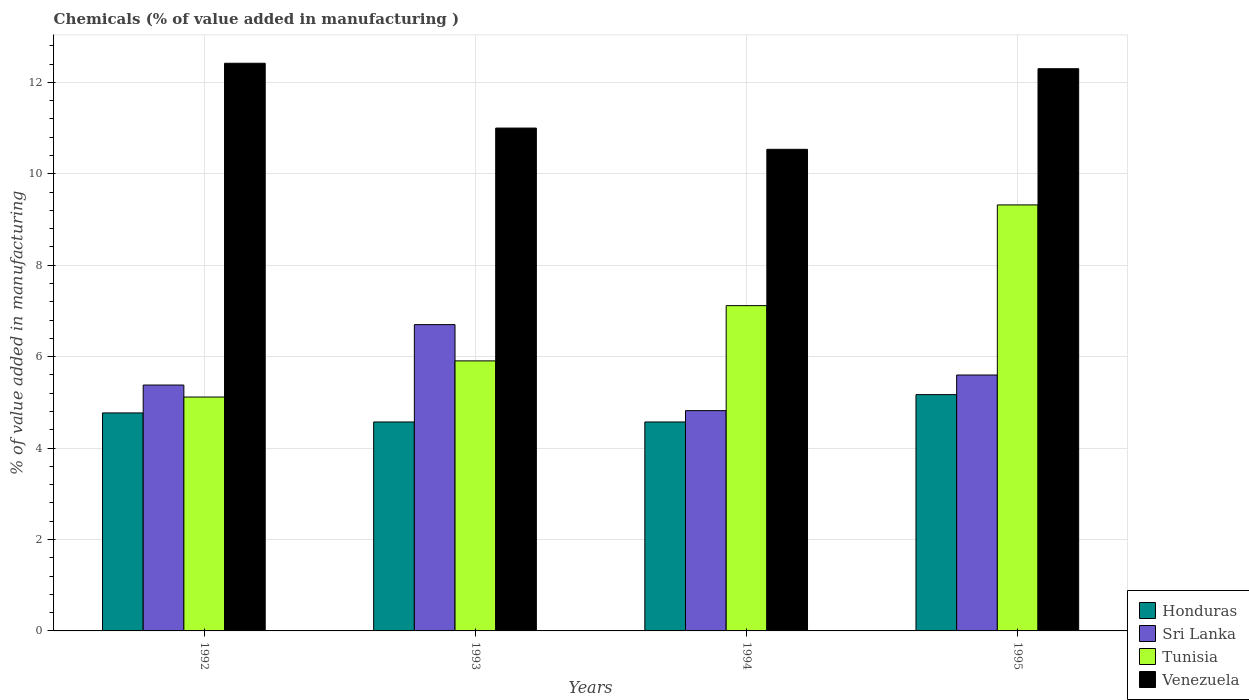What is the label of the 1st group of bars from the left?
Your answer should be compact. 1992. In how many cases, is the number of bars for a given year not equal to the number of legend labels?
Ensure brevity in your answer.  0. What is the value added in manufacturing chemicals in Sri Lanka in 1994?
Ensure brevity in your answer.  4.82. Across all years, what is the maximum value added in manufacturing chemicals in Honduras?
Provide a succinct answer. 5.17. Across all years, what is the minimum value added in manufacturing chemicals in Honduras?
Offer a very short reply. 4.57. What is the total value added in manufacturing chemicals in Sri Lanka in the graph?
Give a very brief answer. 22.5. What is the difference between the value added in manufacturing chemicals in Sri Lanka in 1992 and that in 1994?
Ensure brevity in your answer.  0.56. What is the difference between the value added in manufacturing chemicals in Sri Lanka in 1992 and the value added in manufacturing chemicals in Honduras in 1993?
Offer a terse response. 0.81. What is the average value added in manufacturing chemicals in Honduras per year?
Give a very brief answer. 4.77. In the year 1995, what is the difference between the value added in manufacturing chemicals in Sri Lanka and value added in manufacturing chemicals in Honduras?
Ensure brevity in your answer.  0.43. In how many years, is the value added in manufacturing chemicals in Sri Lanka greater than 3.2 %?
Keep it short and to the point. 4. What is the ratio of the value added in manufacturing chemicals in Venezuela in 1993 to that in 1994?
Your answer should be very brief. 1.04. Is the difference between the value added in manufacturing chemicals in Sri Lanka in 1992 and 1995 greater than the difference between the value added in manufacturing chemicals in Honduras in 1992 and 1995?
Ensure brevity in your answer.  Yes. What is the difference between the highest and the second highest value added in manufacturing chemicals in Tunisia?
Provide a succinct answer. 2.2. What is the difference between the highest and the lowest value added in manufacturing chemicals in Honduras?
Give a very brief answer. 0.6. Is it the case that in every year, the sum of the value added in manufacturing chemicals in Honduras and value added in manufacturing chemicals in Venezuela is greater than the sum of value added in manufacturing chemicals in Sri Lanka and value added in manufacturing chemicals in Tunisia?
Offer a terse response. Yes. What does the 4th bar from the left in 1995 represents?
Give a very brief answer. Venezuela. What does the 2nd bar from the right in 1992 represents?
Ensure brevity in your answer.  Tunisia. How many bars are there?
Your answer should be compact. 16. Are all the bars in the graph horizontal?
Provide a succinct answer. No. How many years are there in the graph?
Your answer should be very brief. 4. Are the values on the major ticks of Y-axis written in scientific E-notation?
Your answer should be compact. No. Does the graph contain any zero values?
Your response must be concise. No. How are the legend labels stacked?
Ensure brevity in your answer.  Vertical. What is the title of the graph?
Keep it short and to the point. Chemicals (% of value added in manufacturing ). What is the label or title of the Y-axis?
Your answer should be very brief. % of value added in manufacturing. What is the % of value added in manufacturing of Honduras in 1992?
Offer a very short reply. 4.77. What is the % of value added in manufacturing in Sri Lanka in 1992?
Make the answer very short. 5.38. What is the % of value added in manufacturing in Tunisia in 1992?
Offer a terse response. 5.12. What is the % of value added in manufacturing of Venezuela in 1992?
Your answer should be very brief. 12.42. What is the % of value added in manufacturing of Honduras in 1993?
Your answer should be very brief. 4.57. What is the % of value added in manufacturing of Sri Lanka in 1993?
Provide a succinct answer. 6.7. What is the % of value added in manufacturing of Tunisia in 1993?
Your answer should be compact. 5.91. What is the % of value added in manufacturing of Venezuela in 1993?
Provide a short and direct response. 11. What is the % of value added in manufacturing in Honduras in 1994?
Make the answer very short. 4.57. What is the % of value added in manufacturing of Sri Lanka in 1994?
Your answer should be compact. 4.82. What is the % of value added in manufacturing in Tunisia in 1994?
Provide a succinct answer. 7.12. What is the % of value added in manufacturing of Venezuela in 1994?
Offer a terse response. 10.54. What is the % of value added in manufacturing in Honduras in 1995?
Your response must be concise. 5.17. What is the % of value added in manufacturing in Sri Lanka in 1995?
Offer a very short reply. 5.6. What is the % of value added in manufacturing of Tunisia in 1995?
Your answer should be very brief. 9.32. What is the % of value added in manufacturing in Venezuela in 1995?
Your response must be concise. 12.3. Across all years, what is the maximum % of value added in manufacturing in Honduras?
Provide a short and direct response. 5.17. Across all years, what is the maximum % of value added in manufacturing in Sri Lanka?
Offer a terse response. 6.7. Across all years, what is the maximum % of value added in manufacturing of Tunisia?
Your answer should be very brief. 9.32. Across all years, what is the maximum % of value added in manufacturing of Venezuela?
Ensure brevity in your answer.  12.42. Across all years, what is the minimum % of value added in manufacturing of Honduras?
Give a very brief answer. 4.57. Across all years, what is the minimum % of value added in manufacturing of Sri Lanka?
Keep it short and to the point. 4.82. Across all years, what is the minimum % of value added in manufacturing of Tunisia?
Provide a succinct answer. 5.12. Across all years, what is the minimum % of value added in manufacturing in Venezuela?
Your answer should be very brief. 10.54. What is the total % of value added in manufacturing of Honduras in the graph?
Make the answer very short. 19.08. What is the total % of value added in manufacturing in Sri Lanka in the graph?
Make the answer very short. 22.5. What is the total % of value added in manufacturing of Tunisia in the graph?
Give a very brief answer. 27.46. What is the total % of value added in manufacturing of Venezuela in the graph?
Give a very brief answer. 46.25. What is the difference between the % of value added in manufacturing in Honduras in 1992 and that in 1993?
Make the answer very short. 0.2. What is the difference between the % of value added in manufacturing in Sri Lanka in 1992 and that in 1993?
Provide a short and direct response. -1.32. What is the difference between the % of value added in manufacturing of Tunisia in 1992 and that in 1993?
Ensure brevity in your answer.  -0.79. What is the difference between the % of value added in manufacturing of Venezuela in 1992 and that in 1993?
Offer a very short reply. 1.42. What is the difference between the % of value added in manufacturing of Honduras in 1992 and that in 1994?
Give a very brief answer. 0.2. What is the difference between the % of value added in manufacturing in Sri Lanka in 1992 and that in 1994?
Make the answer very short. 0.56. What is the difference between the % of value added in manufacturing of Tunisia in 1992 and that in 1994?
Keep it short and to the point. -2. What is the difference between the % of value added in manufacturing in Venezuela in 1992 and that in 1994?
Provide a short and direct response. 1.88. What is the difference between the % of value added in manufacturing of Honduras in 1992 and that in 1995?
Provide a short and direct response. -0.4. What is the difference between the % of value added in manufacturing in Sri Lanka in 1992 and that in 1995?
Ensure brevity in your answer.  -0.22. What is the difference between the % of value added in manufacturing of Tunisia in 1992 and that in 1995?
Give a very brief answer. -4.2. What is the difference between the % of value added in manufacturing in Venezuela in 1992 and that in 1995?
Make the answer very short. 0.12. What is the difference between the % of value added in manufacturing of Sri Lanka in 1993 and that in 1994?
Your answer should be very brief. 1.88. What is the difference between the % of value added in manufacturing of Tunisia in 1993 and that in 1994?
Provide a short and direct response. -1.21. What is the difference between the % of value added in manufacturing of Venezuela in 1993 and that in 1994?
Give a very brief answer. 0.47. What is the difference between the % of value added in manufacturing in Honduras in 1993 and that in 1995?
Provide a short and direct response. -0.6. What is the difference between the % of value added in manufacturing in Sri Lanka in 1993 and that in 1995?
Your response must be concise. 1.1. What is the difference between the % of value added in manufacturing in Tunisia in 1993 and that in 1995?
Your answer should be very brief. -3.41. What is the difference between the % of value added in manufacturing of Venezuela in 1993 and that in 1995?
Provide a short and direct response. -1.3. What is the difference between the % of value added in manufacturing in Honduras in 1994 and that in 1995?
Offer a terse response. -0.6. What is the difference between the % of value added in manufacturing of Sri Lanka in 1994 and that in 1995?
Offer a very short reply. -0.78. What is the difference between the % of value added in manufacturing of Tunisia in 1994 and that in 1995?
Give a very brief answer. -2.2. What is the difference between the % of value added in manufacturing of Venezuela in 1994 and that in 1995?
Provide a short and direct response. -1.76. What is the difference between the % of value added in manufacturing of Honduras in 1992 and the % of value added in manufacturing of Sri Lanka in 1993?
Give a very brief answer. -1.93. What is the difference between the % of value added in manufacturing of Honduras in 1992 and the % of value added in manufacturing of Tunisia in 1993?
Give a very brief answer. -1.14. What is the difference between the % of value added in manufacturing of Honduras in 1992 and the % of value added in manufacturing of Venezuela in 1993?
Your response must be concise. -6.23. What is the difference between the % of value added in manufacturing of Sri Lanka in 1992 and the % of value added in manufacturing of Tunisia in 1993?
Your answer should be compact. -0.53. What is the difference between the % of value added in manufacturing in Sri Lanka in 1992 and the % of value added in manufacturing in Venezuela in 1993?
Your answer should be compact. -5.62. What is the difference between the % of value added in manufacturing in Tunisia in 1992 and the % of value added in manufacturing in Venezuela in 1993?
Offer a terse response. -5.88. What is the difference between the % of value added in manufacturing in Honduras in 1992 and the % of value added in manufacturing in Sri Lanka in 1994?
Make the answer very short. -0.05. What is the difference between the % of value added in manufacturing of Honduras in 1992 and the % of value added in manufacturing of Tunisia in 1994?
Make the answer very short. -2.35. What is the difference between the % of value added in manufacturing in Honduras in 1992 and the % of value added in manufacturing in Venezuela in 1994?
Keep it short and to the point. -5.77. What is the difference between the % of value added in manufacturing of Sri Lanka in 1992 and the % of value added in manufacturing of Tunisia in 1994?
Give a very brief answer. -1.74. What is the difference between the % of value added in manufacturing of Sri Lanka in 1992 and the % of value added in manufacturing of Venezuela in 1994?
Give a very brief answer. -5.16. What is the difference between the % of value added in manufacturing of Tunisia in 1992 and the % of value added in manufacturing of Venezuela in 1994?
Give a very brief answer. -5.42. What is the difference between the % of value added in manufacturing of Honduras in 1992 and the % of value added in manufacturing of Sri Lanka in 1995?
Provide a succinct answer. -0.83. What is the difference between the % of value added in manufacturing of Honduras in 1992 and the % of value added in manufacturing of Tunisia in 1995?
Offer a very short reply. -4.55. What is the difference between the % of value added in manufacturing of Honduras in 1992 and the % of value added in manufacturing of Venezuela in 1995?
Your response must be concise. -7.53. What is the difference between the % of value added in manufacturing in Sri Lanka in 1992 and the % of value added in manufacturing in Tunisia in 1995?
Offer a very short reply. -3.94. What is the difference between the % of value added in manufacturing in Sri Lanka in 1992 and the % of value added in manufacturing in Venezuela in 1995?
Provide a succinct answer. -6.92. What is the difference between the % of value added in manufacturing of Tunisia in 1992 and the % of value added in manufacturing of Venezuela in 1995?
Offer a very short reply. -7.18. What is the difference between the % of value added in manufacturing of Honduras in 1993 and the % of value added in manufacturing of Sri Lanka in 1994?
Provide a succinct answer. -0.25. What is the difference between the % of value added in manufacturing in Honduras in 1993 and the % of value added in manufacturing in Tunisia in 1994?
Provide a succinct answer. -2.55. What is the difference between the % of value added in manufacturing of Honduras in 1993 and the % of value added in manufacturing of Venezuela in 1994?
Your answer should be compact. -5.96. What is the difference between the % of value added in manufacturing of Sri Lanka in 1993 and the % of value added in manufacturing of Tunisia in 1994?
Offer a very short reply. -0.42. What is the difference between the % of value added in manufacturing of Sri Lanka in 1993 and the % of value added in manufacturing of Venezuela in 1994?
Ensure brevity in your answer.  -3.83. What is the difference between the % of value added in manufacturing in Tunisia in 1993 and the % of value added in manufacturing in Venezuela in 1994?
Your response must be concise. -4.63. What is the difference between the % of value added in manufacturing in Honduras in 1993 and the % of value added in manufacturing in Sri Lanka in 1995?
Provide a succinct answer. -1.03. What is the difference between the % of value added in manufacturing in Honduras in 1993 and the % of value added in manufacturing in Tunisia in 1995?
Offer a terse response. -4.75. What is the difference between the % of value added in manufacturing in Honduras in 1993 and the % of value added in manufacturing in Venezuela in 1995?
Your response must be concise. -7.73. What is the difference between the % of value added in manufacturing of Sri Lanka in 1993 and the % of value added in manufacturing of Tunisia in 1995?
Keep it short and to the point. -2.62. What is the difference between the % of value added in manufacturing of Sri Lanka in 1993 and the % of value added in manufacturing of Venezuela in 1995?
Make the answer very short. -5.6. What is the difference between the % of value added in manufacturing in Tunisia in 1993 and the % of value added in manufacturing in Venezuela in 1995?
Your answer should be very brief. -6.39. What is the difference between the % of value added in manufacturing of Honduras in 1994 and the % of value added in manufacturing of Sri Lanka in 1995?
Ensure brevity in your answer.  -1.03. What is the difference between the % of value added in manufacturing in Honduras in 1994 and the % of value added in manufacturing in Tunisia in 1995?
Keep it short and to the point. -4.75. What is the difference between the % of value added in manufacturing in Honduras in 1994 and the % of value added in manufacturing in Venezuela in 1995?
Provide a short and direct response. -7.73. What is the difference between the % of value added in manufacturing in Sri Lanka in 1994 and the % of value added in manufacturing in Tunisia in 1995?
Your response must be concise. -4.5. What is the difference between the % of value added in manufacturing in Sri Lanka in 1994 and the % of value added in manufacturing in Venezuela in 1995?
Keep it short and to the point. -7.48. What is the difference between the % of value added in manufacturing of Tunisia in 1994 and the % of value added in manufacturing of Venezuela in 1995?
Your answer should be compact. -5.18. What is the average % of value added in manufacturing of Honduras per year?
Give a very brief answer. 4.77. What is the average % of value added in manufacturing in Sri Lanka per year?
Your answer should be compact. 5.62. What is the average % of value added in manufacturing in Tunisia per year?
Your answer should be compact. 6.87. What is the average % of value added in manufacturing of Venezuela per year?
Your answer should be very brief. 11.56. In the year 1992, what is the difference between the % of value added in manufacturing of Honduras and % of value added in manufacturing of Sri Lanka?
Offer a very short reply. -0.61. In the year 1992, what is the difference between the % of value added in manufacturing in Honduras and % of value added in manufacturing in Tunisia?
Give a very brief answer. -0.35. In the year 1992, what is the difference between the % of value added in manufacturing in Honduras and % of value added in manufacturing in Venezuela?
Your answer should be very brief. -7.65. In the year 1992, what is the difference between the % of value added in manufacturing in Sri Lanka and % of value added in manufacturing in Tunisia?
Your response must be concise. 0.26. In the year 1992, what is the difference between the % of value added in manufacturing in Sri Lanka and % of value added in manufacturing in Venezuela?
Make the answer very short. -7.04. In the year 1992, what is the difference between the % of value added in manufacturing of Tunisia and % of value added in manufacturing of Venezuela?
Offer a very short reply. -7.3. In the year 1993, what is the difference between the % of value added in manufacturing of Honduras and % of value added in manufacturing of Sri Lanka?
Offer a terse response. -2.13. In the year 1993, what is the difference between the % of value added in manufacturing in Honduras and % of value added in manufacturing in Tunisia?
Your answer should be compact. -1.34. In the year 1993, what is the difference between the % of value added in manufacturing in Honduras and % of value added in manufacturing in Venezuela?
Provide a succinct answer. -6.43. In the year 1993, what is the difference between the % of value added in manufacturing in Sri Lanka and % of value added in manufacturing in Tunisia?
Your response must be concise. 0.79. In the year 1993, what is the difference between the % of value added in manufacturing of Sri Lanka and % of value added in manufacturing of Venezuela?
Make the answer very short. -4.3. In the year 1993, what is the difference between the % of value added in manufacturing of Tunisia and % of value added in manufacturing of Venezuela?
Offer a very short reply. -5.09. In the year 1994, what is the difference between the % of value added in manufacturing in Honduras and % of value added in manufacturing in Sri Lanka?
Your answer should be very brief. -0.25. In the year 1994, what is the difference between the % of value added in manufacturing of Honduras and % of value added in manufacturing of Tunisia?
Ensure brevity in your answer.  -2.55. In the year 1994, what is the difference between the % of value added in manufacturing in Honduras and % of value added in manufacturing in Venezuela?
Your answer should be very brief. -5.96. In the year 1994, what is the difference between the % of value added in manufacturing of Sri Lanka and % of value added in manufacturing of Tunisia?
Make the answer very short. -2.3. In the year 1994, what is the difference between the % of value added in manufacturing in Sri Lanka and % of value added in manufacturing in Venezuela?
Offer a very short reply. -5.72. In the year 1994, what is the difference between the % of value added in manufacturing in Tunisia and % of value added in manufacturing in Venezuela?
Your response must be concise. -3.42. In the year 1995, what is the difference between the % of value added in manufacturing of Honduras and % of value added in manufacturing of Sri Lanka?
Your response must be concise. -0.43. In the year 1995, what is the difference between the % of value added in manufacturing of Honduras and % of value added in manufacturing of Tunisia?
Provide a succinct answer. -4.15. In the year 1995, what is the difference between the % of value added in manufacturing of Honduras and % of value added in manufacturing of Venezuela?
Provide a succinct answer. -7.13. In the year 1995, what is the difference between the % of value added in manufacturing in Sri Lanka and % of value added in manufacturing in Tunisia?
Give a very brief answer. -3.72. In the year 1995, what is the difference between the % of value added in manufacturing of Sri Lanka and % of value added in manufacturing of Venezuela?
Provide a succinct answer. -6.7. In the year 1995, what is the difference between the % of value added in manufacturing in Tunisia and % of value added in manufacturing in Venezuela?
Provide a succinct answer. -2.98. What is the ratio of the % of value added in manufacturing of Honduras in 1992 to that in 1993?
Make the answer very short. 1.04. What is the ratio of the % of value added in manufacturing in Sri Lanka in 1992 to that in 1993?
Offer a very short reply. 0.8. What is the ratio of the % of value added in manufacturing in Tunisia in 1992 to that in 1993?
Make the answer very short. 0.87. What is the ratio of the % of value added in manufacturing of Venezuela in 1992 to that in 1993?
Give a very brief answer. 1.13. What is the ratio of the % of value added in manufacturing in Honduras in 1992 to that in 1994?
Ensure brevity in your answer.  1.04. What is the ratio of the % of value added in manufacturing of Sri Lanka in 1992 to that in 1994?
Offer a terse response. 1.12. What is the ratio of the % of value added in manufacturing in Tunisia in 1992 to that in 1994?
Your response must be concise. 0.72. What is the ratio of the % of value added in manufacturing in Venezuela in 1992 to that in 1994?
Provide a succinct answer. 1.18. What is the ratio of the % of value added in manufacturing in Honduras in 1992 to that in 1995?
Your answer should be very brief. 0.92. What is the ratio of the % of value added in manufacturing in Sri Lanka in 1992 to that in 1995?
Make the answer very short. 0.96. What is the ratio of the % of value added in manufacturing of Tunisia in 1992 to that in 1995?
Ensure brevity in your answer.  0.55. What is the ratio of the % of value added in manufacturing of Venezuela in 1992 to that in 1995?
Your answer should be very brief. 1.01. What is the ratio of the % of value added in manufacturing of Honduras in 1993 to that in 1994?
Make the answer very short. 1. What is the ratio of the % of value added in manufacturing of Sri Lanka in 1993 to that in 1994?
Your answer should be compact. 1.39. What is the ratio of the % of value added in manufacturing of Tunisia in 1993 to that in 1994?
Ensure brevity in your answer.  0.83. What is the ratio of the % of value added in manufacturing of Venezuela in 1993 to that in 1994?
Ensure brevity in your answer.  1.04. What is the ratio of the % of value added in manufacturing of Honduras in 1993 to that in 1995?
Offer a terse response. 0.88. What is the ratio of the % of value added in manufacturing in Sri Lanka in 1993 to that in 1995?
Your answer should be very brief. 1.2. What is the ratio of the % of value added in manufacturing of Tunisia in 1993 to that in 1995?
Ensure brevity in your answer.  0.63. What is the ratio of the % of value added in manufacturing in Venezuela in 1993 to that in 1995?
Your response must be concise. 0.89. What is the ratio of the % of value added in manufacturing in Honduras in 1994 to that in 1995?
Provide a succinct answer. 0.88. What is the ratio of the % of value added in manufacturing in Sri Lanka in 1994 to that in 1995?
Give a very brief answer. 0.86. What is the ratio of the % of value added in manufacturing of Tunisia in 1994 to that in 1995?
Provide a short and direct response. 0.76. What is the ratio of the % of value added in manufacturing in Venezuela in 1994 to that in 1995?
Your answer should be very brief. 0.86. What is the difference between the highest and the second highest % of value added in manufacturing in Honduras?
Give a very brief answer. 0.4. What is the difference between the highest and the second highest % of value added in manufacturing in Sri Lanka?
Your answer should be very brief. 1.1. What is the difference between the highest and the second highest % of value added in manufacturing in Tunisia?
Provide a short and direct response. 2.2. What is the difference between the highest and the second highest % of value added in manufacturing in Venezuela?
Provide a short and direct response. 0.12. What is the difference between the highest and the lowest % of value added in manufacturing of Honduras?
Provide a short and direct response. 0.6. What is the difference between the highest and the lowest % of value added in manufacturing of Sri Lanka?
Your answer should be compact. 1.88. What is the difference between the highest and the lowest % of value added in manufacturing in Tunisia?
Give a very brief answer. 4.2. What is the difference between the highest and the lowest % of value added in manufacturing of Venezuela?
Your answer should be very brief. 1.88. 